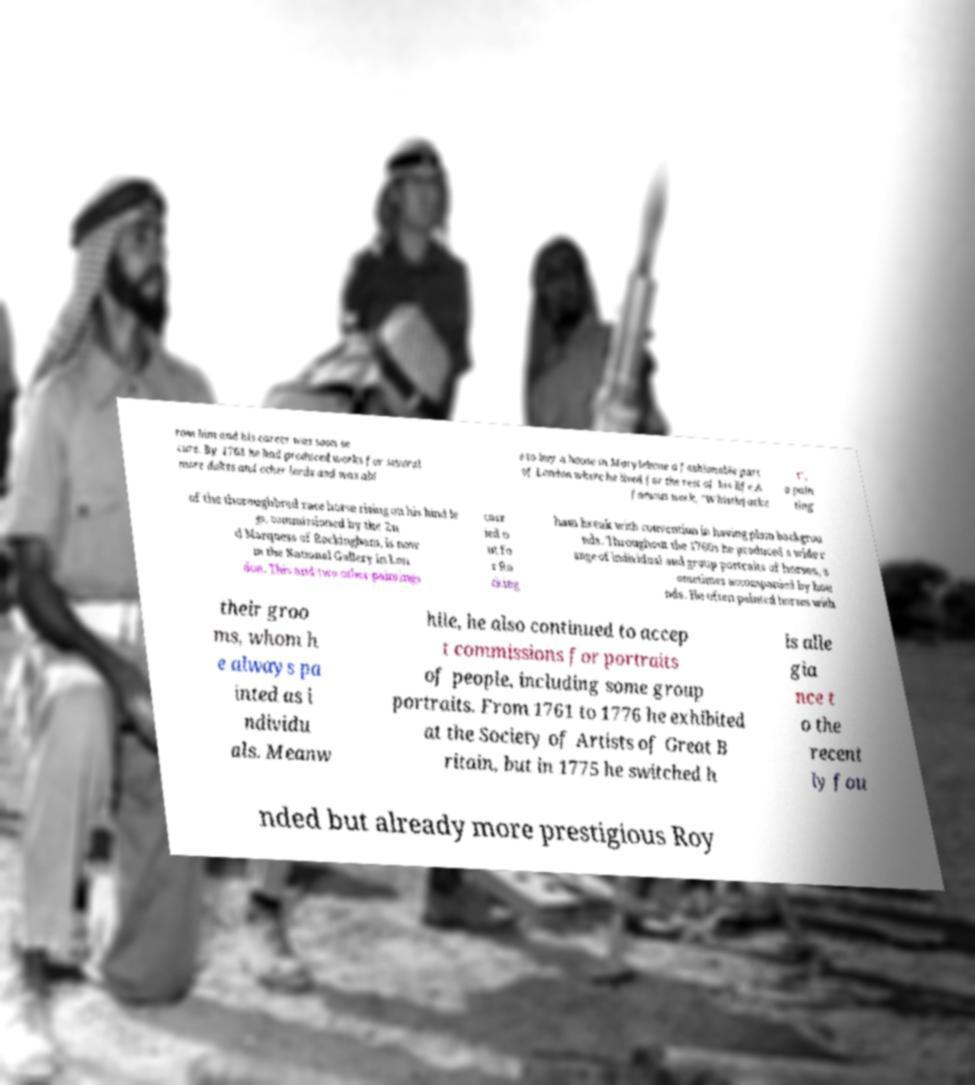Please read and relay the text visible in this image. What does it say? rom him and his career was soon se cure. By 1763 he had produced works for several more dukes and other lords and was abl e to buy a house in Marylebone a fashionable part of London where he lived for the rest of his life.A famous work, "Whistlejacke t", a pain ting of the thoroughbred race horse rising on his hind le gs, commissioned by the 2n d Marquess of Rockingham, is now in the National Gallery in Lon don. This and two other paintings carr ied o ut fo r Ro cking ham break with convention in having plain backgrou nds. Throughout the 1760s he produced a wide r ange of individual and group portraits of horses, s ometimes accompanied by hou nds. He often painted horses with their groo ms, whom h e always pa inted as i ndividu als. Meanw hile, he also continued to accep t commissions for portraits of people, including some group portraits. From 1761 to 1776 he exhibited at the Society of Artists of Great B ritain, but in 1775 he switched h is alle gia nce t o the recent ly fou nded but already more prestigious Roy 